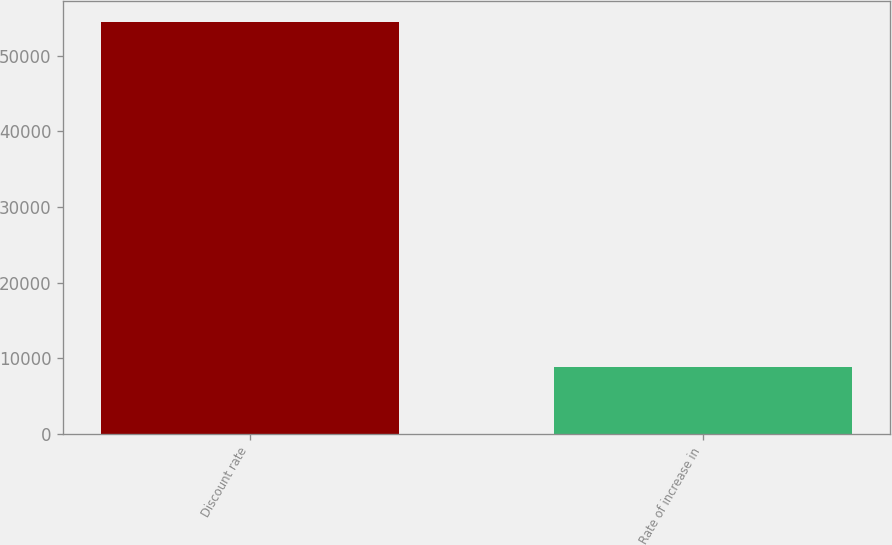<chart> <loc_0><loc_0><loc_500><loc_500><bar_chart><fcel>Discount rate<fcel>Rate of increase in<nl><fcel>54506<fcel>8824<nl></chart> 